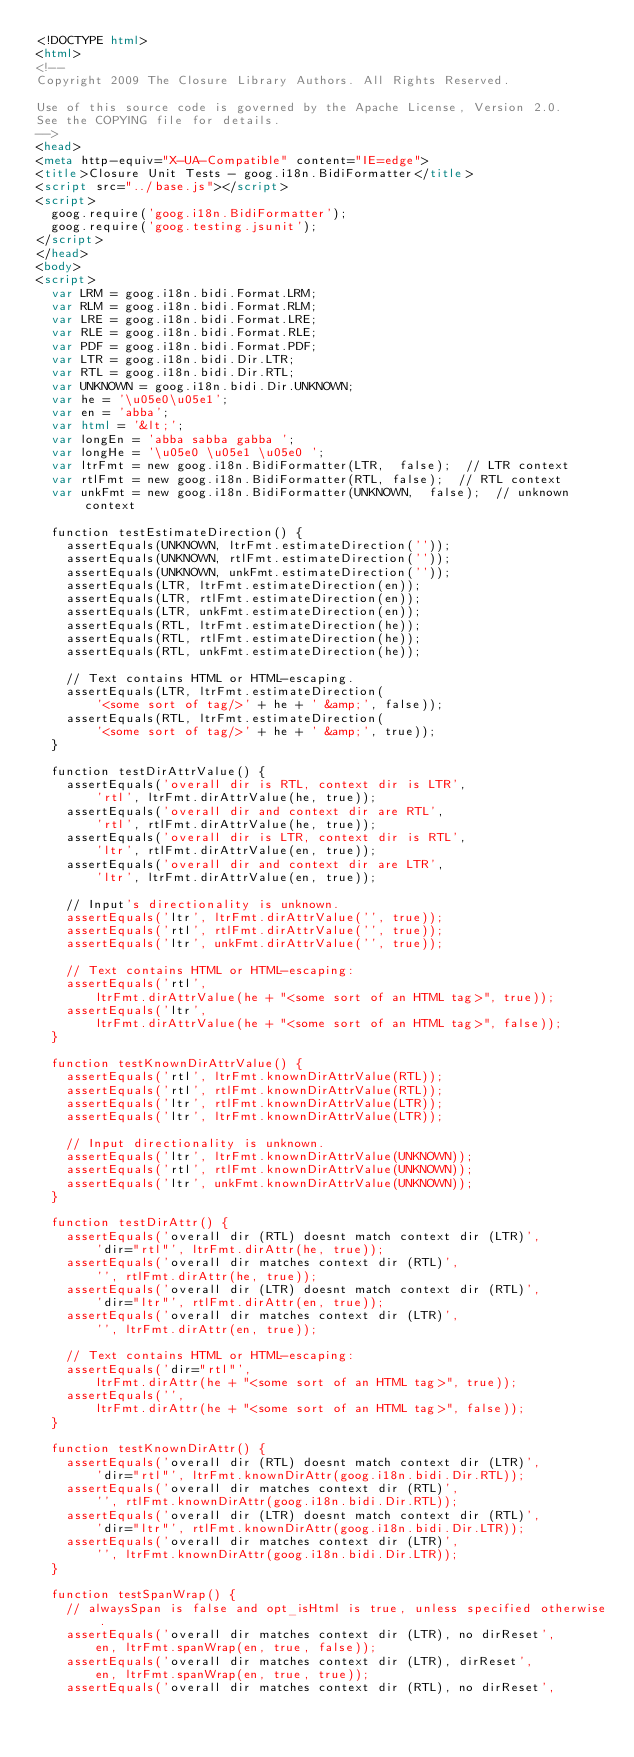Convert code to text. <code><loc_0><loc_0><loc_500><loc_500><_HTML_><!DOCTYPE html>
<html>
<!--
Copyright 2009 The Closure Library Authors. All Rights Reserved.

Use of this source code is governed by the Apache License, Version 2.0.
See the COPYING file for details.
-->
<head>
<meta http-equiv="X-UA-Compatible" content="IE=edge">
<title>Closure Unit Tests - goog.i18n.BidiFormatter</title>
<script src="../base.js"></script>
<script>
  goog.require('goog.i18n.BidiFormatter');
  goog.require('goog.testing.jsunit');
</script>
</head>
<body>
<script>
  var LRM = goog.i18n.bidi.Format.LRM;
  var RLM = goog.i18n.bidi.Format.RLM;
  var LRE = goog.i18n.bidi.Format.LRE;
  var RLE = goog.i18n.bidi.Format.RLE;
  var PDF = goog.i18n.bidi.Format.PDF;
  var LTR = goog.i18n.bidi.Dir.LTR;
  var RTL = goog.i18n.bidi.Dir.RTL;
  var UNKNOWN = goog.i18n.bidi.Dir.UNKNOWN;
  var he = '\u05e0\u05e1';
  var en = 'abba';
  var html = '&lt;';
  var longEn = 'abba sabba gabba ';
  var longHe = '\u05e0 \u05e1 \u05e0 ';
  var ltrFmt = new goog.i18n.BidiFormatter(LTR,  false);  // LTR context
  var rtlFmt = new goog.i18n.BidiFormatter(RTL, false);  // RTL context
  var unkFmt = new goog.i18n.BidiFormatter(UNKNOWN,  false);  // unknown context

  function testEstimateDirection() {
    assertEquals(UNKNOWN, ltrFmt.estimateDirection(''));
    assertEquals(UNKNOWN, rtlFmt.estimateDirection(''));
    assertEquals(UNKNOWN, unkFmt.estimateDirection(''));
    assertEquals(LTR, ltrFmt.estimateDirection(en));
    assertEquals(LTR, rtlFmt.estimateDirection(en));
    assertEquals(LTR, unkFmt.estimateDirection(en));
    assertEquals(RTL, ltrFmt.estimateDirection(he));
    assertEquals(RTL, rtlFmt.estimateDirection(he));
    assertEquals(RTL, unkFmt.estimateDirection(he));

    // Text contains HTML or HTML-escaping.
    assertEquals(LTR, ltrFmt.estimateDirection(
        '<some sort of tag/>' + he + ' &amp;', false));
    assertEquals(RTL, ltrFmt.estimateDirection(
        '<some sort of tag/>' + he + ' &amp;', true));
  }

  function testDirAttrValue() {
    assertEquals('overall dir is RTL, context dir is LTR',
        'rtl', ltrFmt.dirAttrValue(he, true));
    assertEquals('overall dir and context dir are RTL',
        'rtl', rtlFmt.dirAttrValue(he, true));
    assertEquals('overall dir is LTR, context dir is RTL',
        'ltr', rtlFmt.dirAttrValue(en, true));
    assertEquals('overall dir and context dir are LTR',
        'ltr', ltrFmt.dirAttrValue(en, true));

    // Input's directionality is unknown.
    assertEquals('ltr', ltrFmt.dirAttrValue('', true));
    assertEquals('rtl', rtlFmt.dirAttrValue('', true));
    assertEquals('ltr', unkFmt.dirAttrValue('', true));

    // Text contains HTML or HTML-escaping:
    assertEquals('rtl',
        ltrFmt.dirAttrValue(he + "<some sort of an HTML tag>", true));
    assertEquals('ltr',
        ltrFmt.dirAttrValue(he + "<some sort of an HTML tag>", false));
  }

  function testKnownDirAttrValue() {
    assertEquals('rtl', ltrFmt.knownDirAttrValue(RTL));
    assertEquals('rtl', rtlFmt.knownDirAttrValue(RTL));
    assertEquals('ltr', rtlFmt.knownDirAttrValue(LTR));
    assertEquals('ltr', ltrFmt.knownDirAttrValue(LTR));

    // Input directionality is unknown.
    assertEquals('ltr', ltrFmt.knownDirAttrValue(UNKNOWN));
    assertEquals('rtl', rtlFmt.knownDirAttrValue(UNKNOWN));
    assertEquals('ltr', unkFmt.knownDirAttrValue(UNKNOWN));
  }

  function testDirAttr() {
    assertEquals('overall dir (RTL) doesnt match context dir (LTR)',
        'dir="rtl"', ltrFmt.dirAttr(he, true));
    assertEquals('overall dir matches context dir (RTL)',
        '', rtlFmt.dirAttr(he, true));
    assertEquals('overall dir (LTR) doesnt match context dir (RTL)',
        'dir="ltr"', rtlFmt.dirAttr(en, true));
    assertEquals('overall dir matches context dir (LTR)',
        '', ltrFmt.dirAttr(en, true));

    // Text contains HTML or HTML-escaping:
    assertEquals('dir="rtl"',
        ltrFmt.dirAttr(he + "<some sort of an HTML tag>", true));
    assertEquals('',
        ltrFmt.dirAttr(he + "<some sort of an HTML tag>", false));
  }

  function testKnownDirAttr() {
    assertEquals('overall dir (RTL) doesnt match context dir (LTR)',
        'dir="rtl"', ltrFmt.knownDirAttr(goog.i18n.bidi.Dir.RTL));
    assertEquals('overall dir matches context dir (RTL)',
        '', rtlFmt.knownDirAttr(goog.i18n.bidi.Dir.RTL));
    assertEquals('overall dir (LTR) doesnt match context dir (RTL)',
        'dir="ltr"', rtlFmt.knownDirAttr(goog.i18n.bidi.Dir.LTR));
    assertEquals('overall dir matches context dir (LTR)',
        '', ltrFmt.knownDirAttr(goog.i18n.bidi.Dir.LTR));
  }

  function testSpanWrap() {
    // alwaysSpan is false and opt_isHtml is true, unless specified otherwise.
    assertEquals('overall dir matches context dir (LTR), no dirReset',
        en, ltrFmt.spanWrap(en, true, false));
    assertEquals('overall dir matches context dir (LTR), dirReset',
        en, ltrFmt.spanWrap(en, true, true));
    assertEquals('overall dir matches context dir (RTL), no dirReset',</code> 